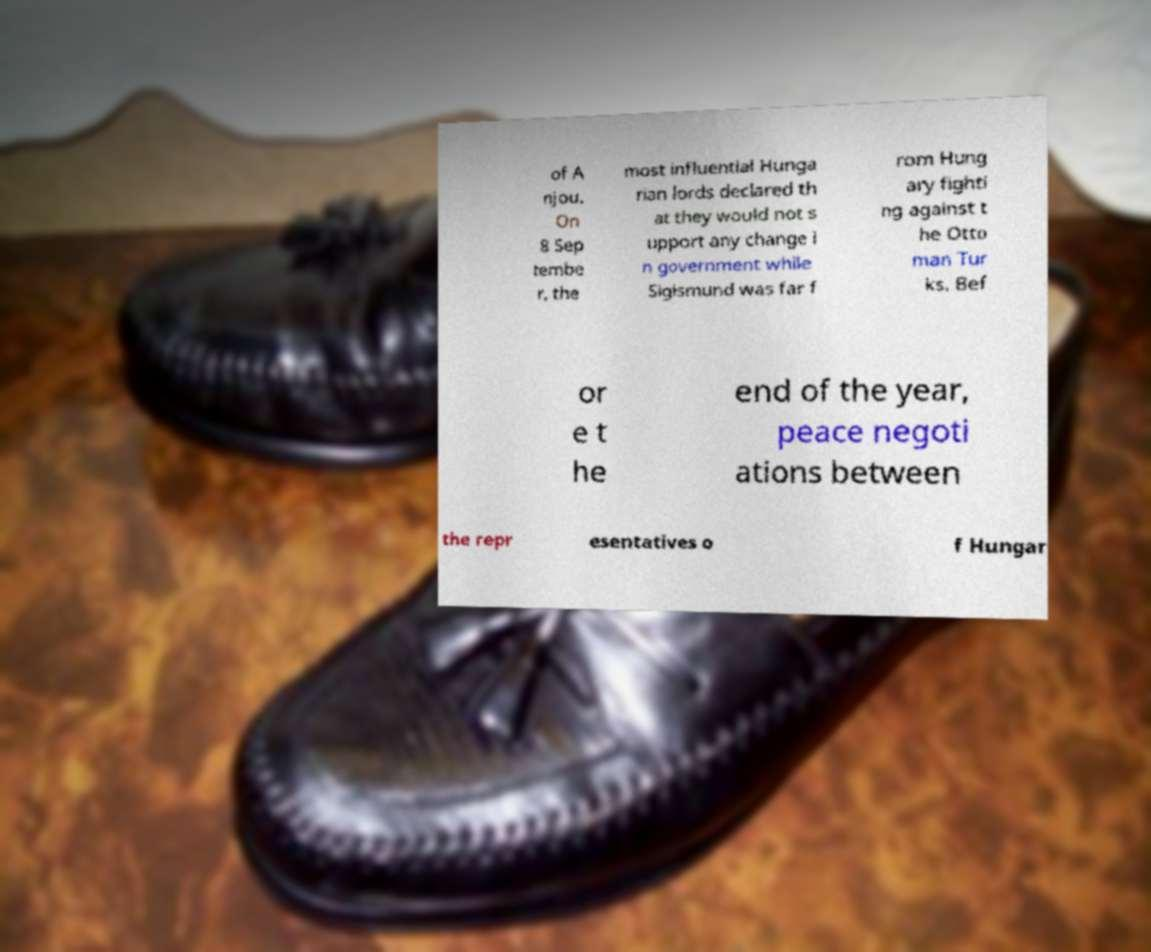Could you assist in decoding the text presented in this image and type it out clearly? of A njou. On 8 Sep tembe r, the most influential Hunga rian lords declared th at they would not s upport any change i n government while Sigismund was far f rom Hung ary fighti ng against t he Otto man Tur ks. Bef or e t he end of the year, peace negoti ations between the repr esentatives o f Hungar 